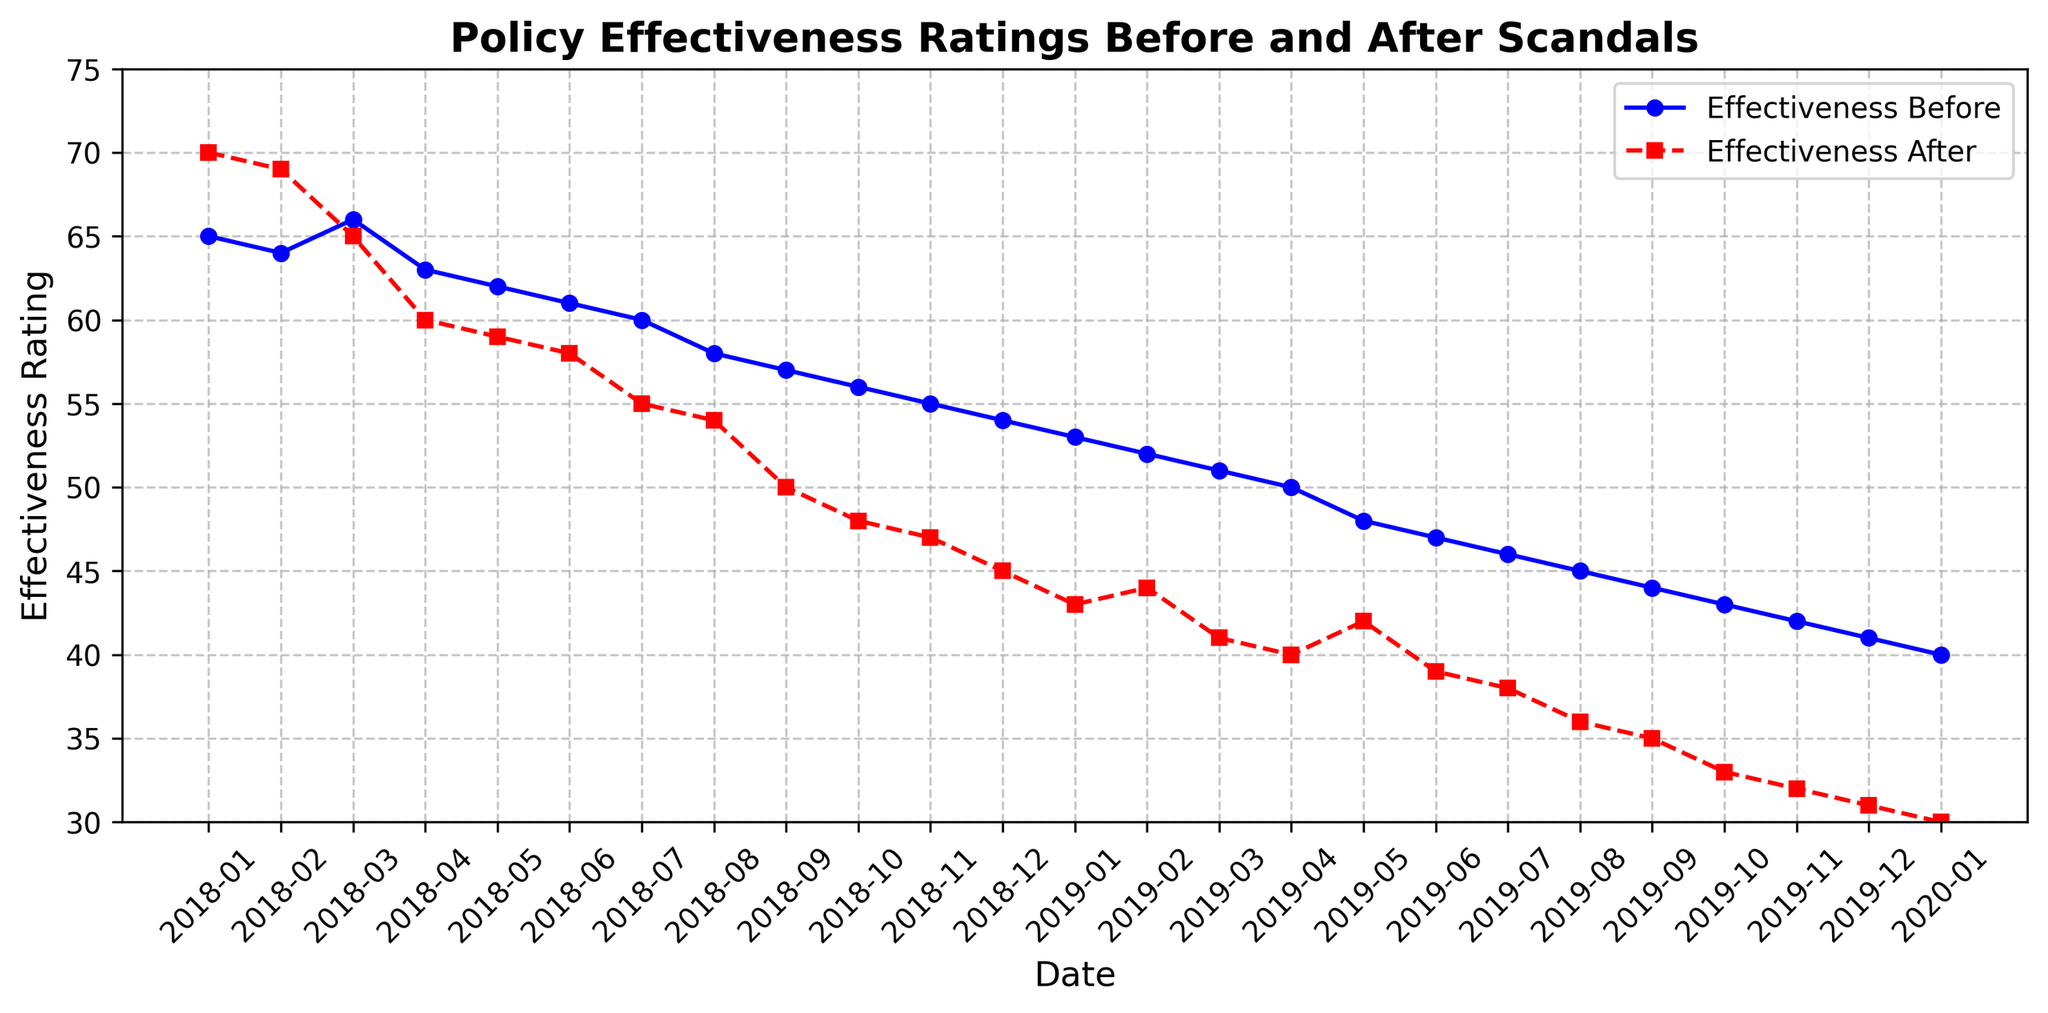When do the effectiveness ratings after the scandals drop below 50? Identify the data points where the effectiveness ratings after the scandals are below 50. This happens from 2018-09 onwards, as the effectiveness rating after the scandals drops to 50 initially and then continues to drop below 50.
Answer: 2018-09 What is the difference in effectiveness ratings before and after the scandals in June 2019? Find the data points for June 2019. The effectiveness rating before the scandals is 47, and the effectiveness rating after the scandals is 39. The difference is 47 - 39 = 8.
Answer: 8 Which month shows the highest effectiveness rating before the scandals? Look at the data and identify the highest effectiveness rating before the scandals. The highest rating is in January 2018, which is 65.
Answer: January 2018 How do the effectiveness ratings after the scandals trend over time? Observe the line representing effectiveness ratings after the scandals. It shows a general decreasing trend, starting at 70 in January 2018 and ending at 30 in January 2020.
Answer: Decreasing Which month has the smallest difference between effectiveness ratings before and after the scandals? Calculate the differences for each month and identify the smallest one. The differences are: 5 (Jan 2018), 5 (Feb 2018), 1 (Mar 2018), etc. The smallest difference is 1 in March 2018.
Answer: March 2018 Does any month in 2019 show an increase in effectiveness ratings after the scandals compared to the previous month? Observe the effectiveness ratings after the scandals line for 2019. All values show a consistent decreasing trend, with no increases month over month.
Answer: No What is the average effectiveness rating before the scandals from January 2018 to January 2020? Sum the effectiveness ratings before the scandals and divide by the number of months (25). (65 + 64 + 66 + 63 + 62 + 61 + 60 + 58 + 57 + 56 + 55 + 54 + 53 + 52 + 51 + 50 + 48 + 47 + 46 + 45 + 44 + 43 + 42 + 41 + 40) = 1300 / 25 = 52.
Answer: 52 Which month shows the steepest decline in effectiveness ratings after the scandals compared to the previous month? Compare month-to-month declines in the effectiveness ratings after the scandals. The steepest decline is from 2018-03 (65) to 2018-04 (60), a drop of 5 points.
Answer: April 2018 How many months show an effectiveness rating before the scandals higher than 50? Count how many months have an effectiveness rating before the scandals greater than 50. Any month before Nov 2019 shows ratings above 50.
Answer: 18 What is the effectiveness rating before the scandals in December 2019? Find the data point for December 2019. The effectiveness rating before the scandals is 41.
Answer: 41 